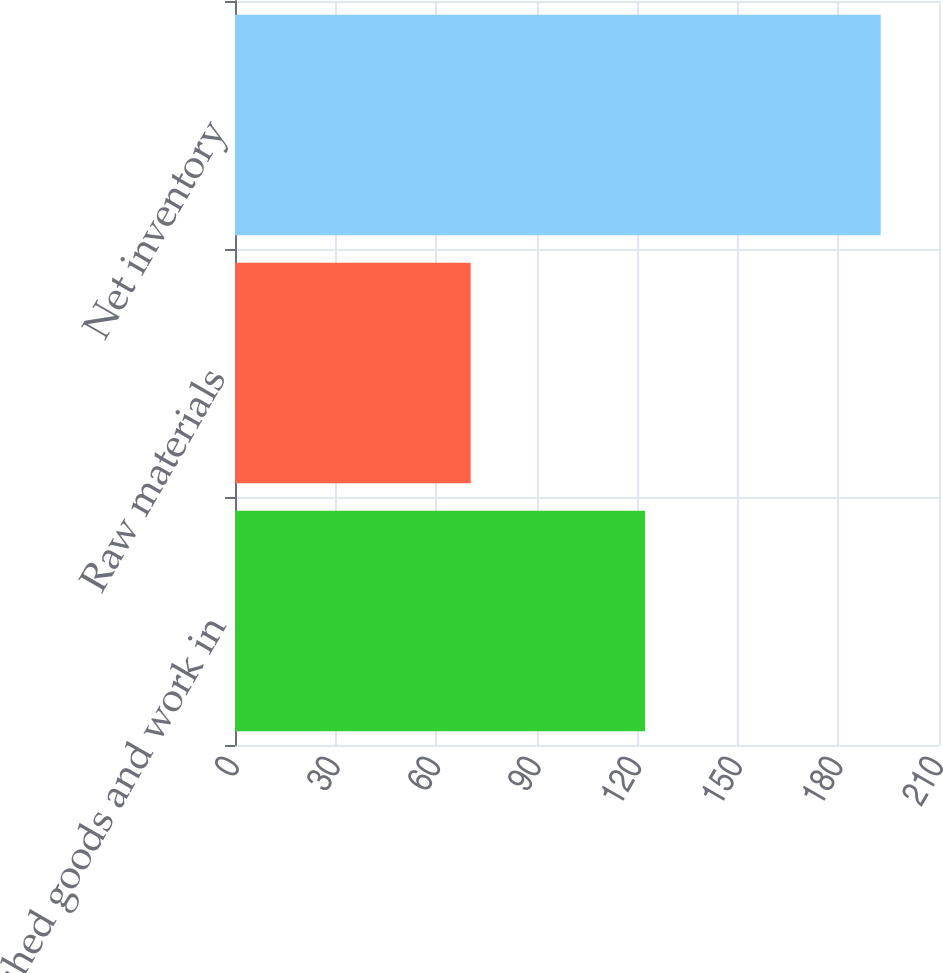Convert chart to OTSL. <chart><loc_0><loc_0><loc_500><loc_500><bar_chart><fcel>Finished goods and work in<fcel>Raw materials<fcel>Net inventory<nl><fcel>122.3<fcel>70.3<fcel>192.6<nl></chart> 